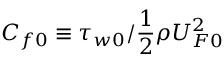Convert formula to latex. <formula><loc_0><loc_0><loc_500><loc_500>C _ { f 0 } \equiv \tau _ { w 0 } / \frac { 1 } { 2 } \rho U _ { F 0 } ^ { 2 }</formula> 